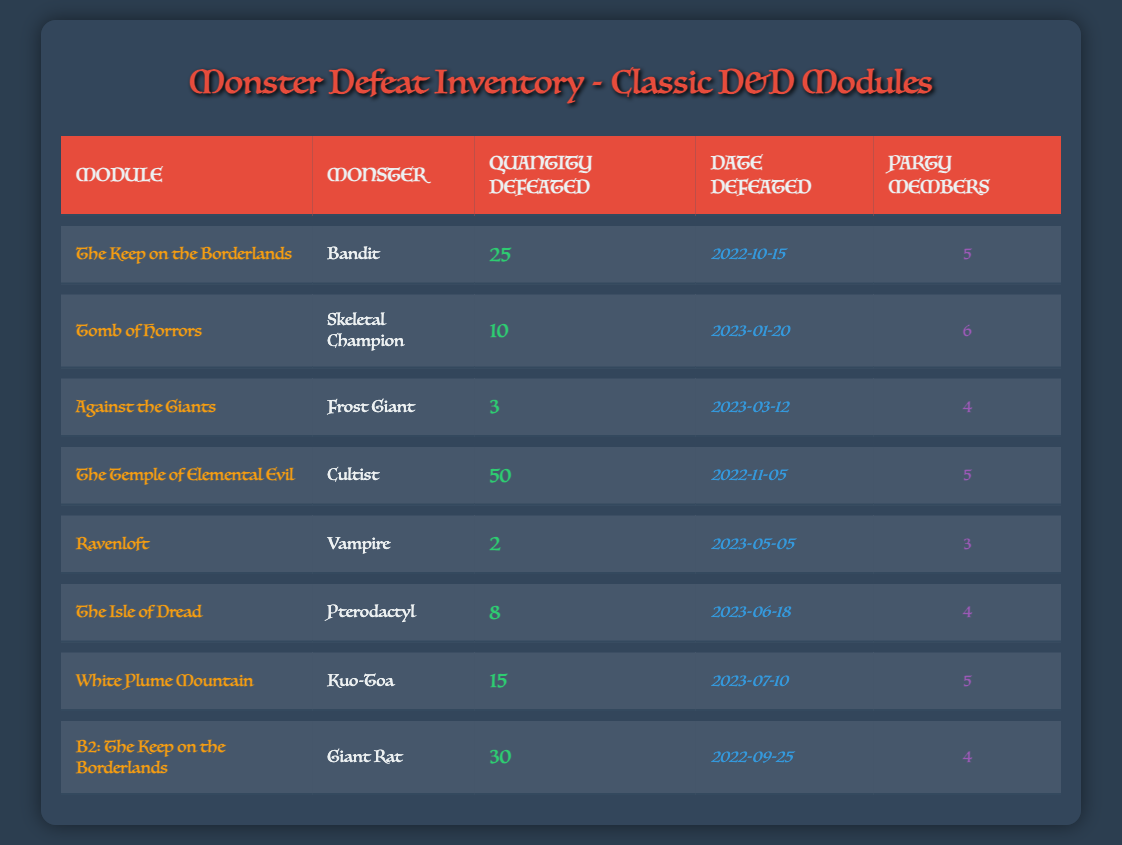What is the total quantity of Frost Giants defeated? There is only one entry for Frost Giants in the table, where it indicates that 3 Frost Giants were defeated.
Answer: 3 Which module had the highest quantity of monsters defeated? The entry for "The Temple of Elemental Evil" lists 50 Cultists defeated, which is the highest number compared to other modules.
Answer: The Temple of Elemental Evil What was the date when the Giant Rats were defeated? The table shows that Giant Rats were defeated on 2022-09-25 in the module "B2: The Keep on the Borderlands."
Answer: 2022-09-25 How many total Pterodactyls and Vampires were defeated combined? There were 8 Pterodactyls and 2 Vampires defeated, so adding these gives 8 + 2 = 10.
Answer: 10 Did the party defeat more than 20 Bandits? The table states that 25 Bandits were defeated, which is indeed more than 20.
Answer: Yes What is the average number of monsters defeated per party member across all entries? To calculate this: Sum the total quantity defeated (25 + 10 + 3 + 50 + 2 + 8 + 15 + 30 = 143) and divide by the total party members (5 + 6 + 4 + 5 + 3 + 4 + 5 + 4 = 36). So, 143 / 36 = approximately 3.97.
Answer: Approximately 3.97 In how many modules did the party defeat at least 4 party members? Reviewing the entries, the modules with 4 or more party members are "The Keep on the Borderlands," "Against the Giants," "The Isle of Dread," "White Plume Mountain," and "B2: The Keep on the Borderlands," giving a total of 5 modules.
Answer: 5 